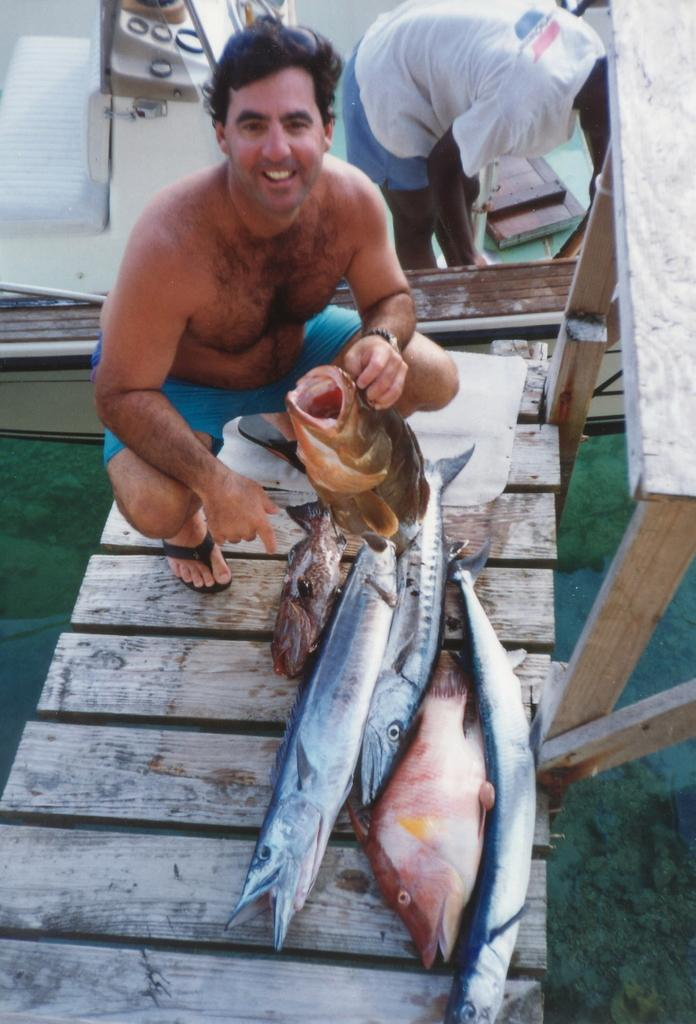What is the main subject of the image? There is a person in the image. Can you describe the person's attire? The person is wearing clothes. What is the person holding in their hand? The person is holding a fish in their hand. What else can be seen in the image related to fish? There are fishes on a bridge in the image. Are there any other people visible in the image? Yes, there is another person in the top right of the image. What is the credit limit of the person holding the fish in the image? There is no information about credit or credit limits in the image, as it focuses on a person holding a fish and other related elements. 